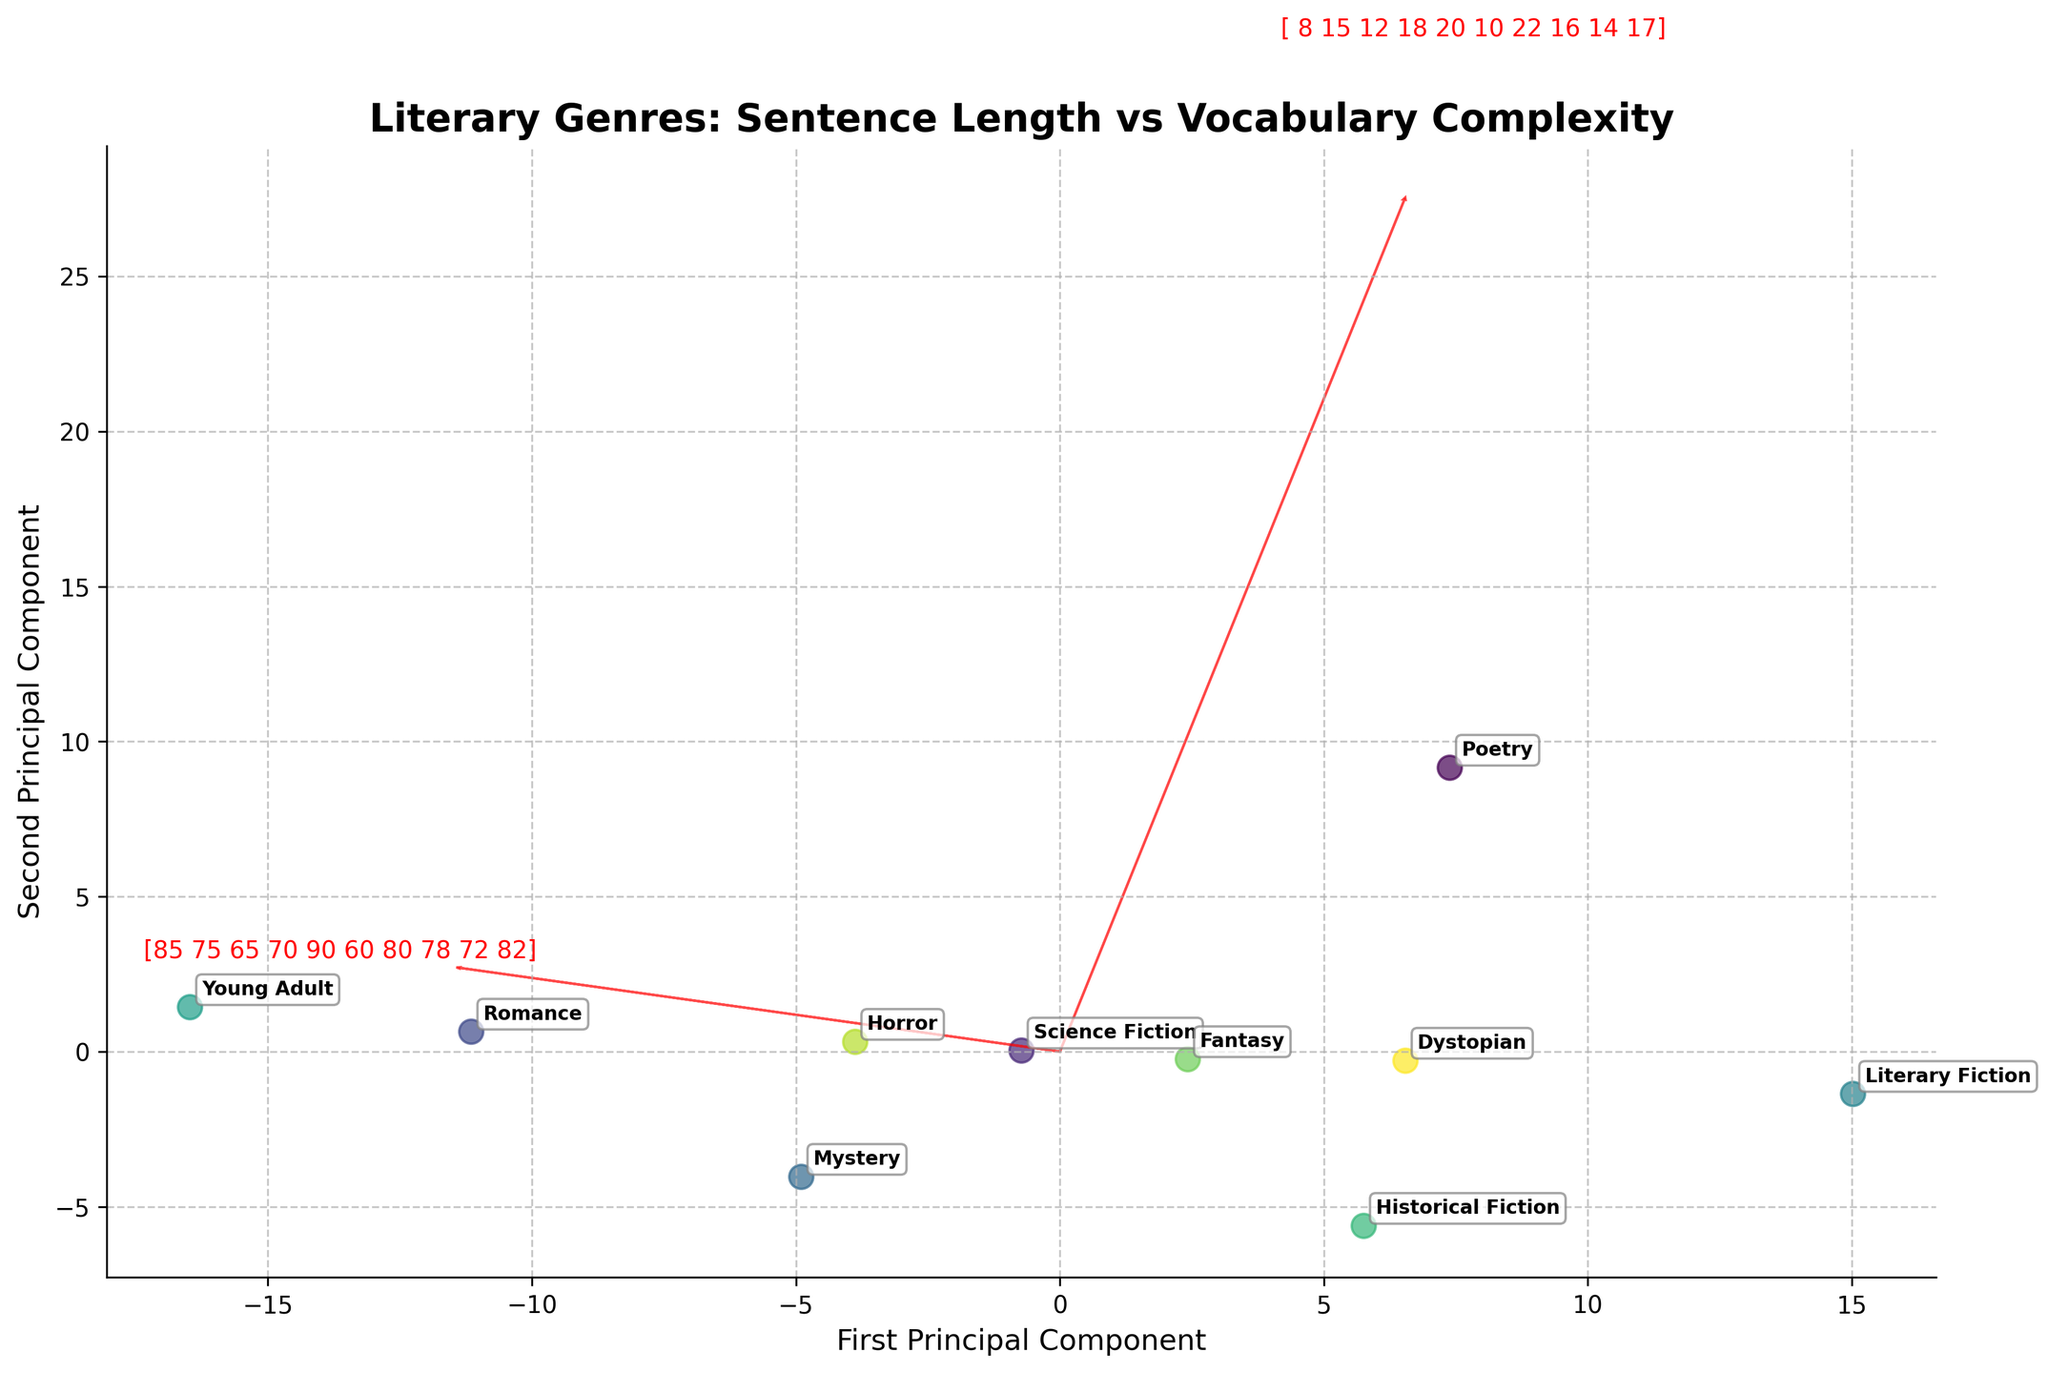What's the title of the figure? The title is written at the top of the figure in a bold, larger font.
Answer: Literary Genres: Sentence Length vs Vocabulary Complexity Which genre has the highest Vocabulary Complexity? From the plotted data points and the annotated genre labels, the genre with the highest position on the Vocabulary Complexity axis is Literary Fiction.
Answer: Literary Fiction What are the axes labels? The labels can be seen on the left and bottom sides of the plot denoting the two principal components that the data is projected onto.
Answer: First Principal Component, Second Principal Component Which genre has the shortest average sentence length? By comparing the positions of the genres along the principal component that represents Avg_Sentence_Length, Poetry has the shortest average sentence length.
Answer: Poetry How many genres are represented in the plot? The data points are annotated with genre labels, and counting these labels will give us the total number of represented genres.
Answer: 10 genres Which two genres are closest to each other in the biplot? By observing the relative distances between the annotated points, Young Adult and Romance are the closest to each other.
Answer: Young Adult, Romance Which feature vectors (arrows) are plotted and labeled on the biplot? The feature vectors for Avg_Sentence_Length and Vocabulary_Complexity are represented by arrows and labeled accordingly.
Answer: Avg_Sentence_Length, Vocabulary_Complexity What is unique about the positioning of Historical Fiction as compared to other genres? Historical Fiction is located far from the origin, indicating it has a distinctive combination of high Avg_Sentence_Length and high Vocabulary_Complexity compared to other genres.
Answer: It is far from the origin Which genre shows a combination of high sentence length and moderate vocabulary complexity? By observing the points' positions, Historical Fiction stands out as having high sentence length and moderate vocabulary complexity.
Answer: Historical Fiction What inference can you draw from the position of Mystery and Horror genres? Mystery and Horror have similar Vocabulary Complexity but differ significantly in Avg_Sentence_Length, as indicated by their positions along the corresponding axes. Mystery has a higher Avg_Sentence_Length than Horror.
Answer: Mystery has a higher Avg_Sentence_Length than Horror 